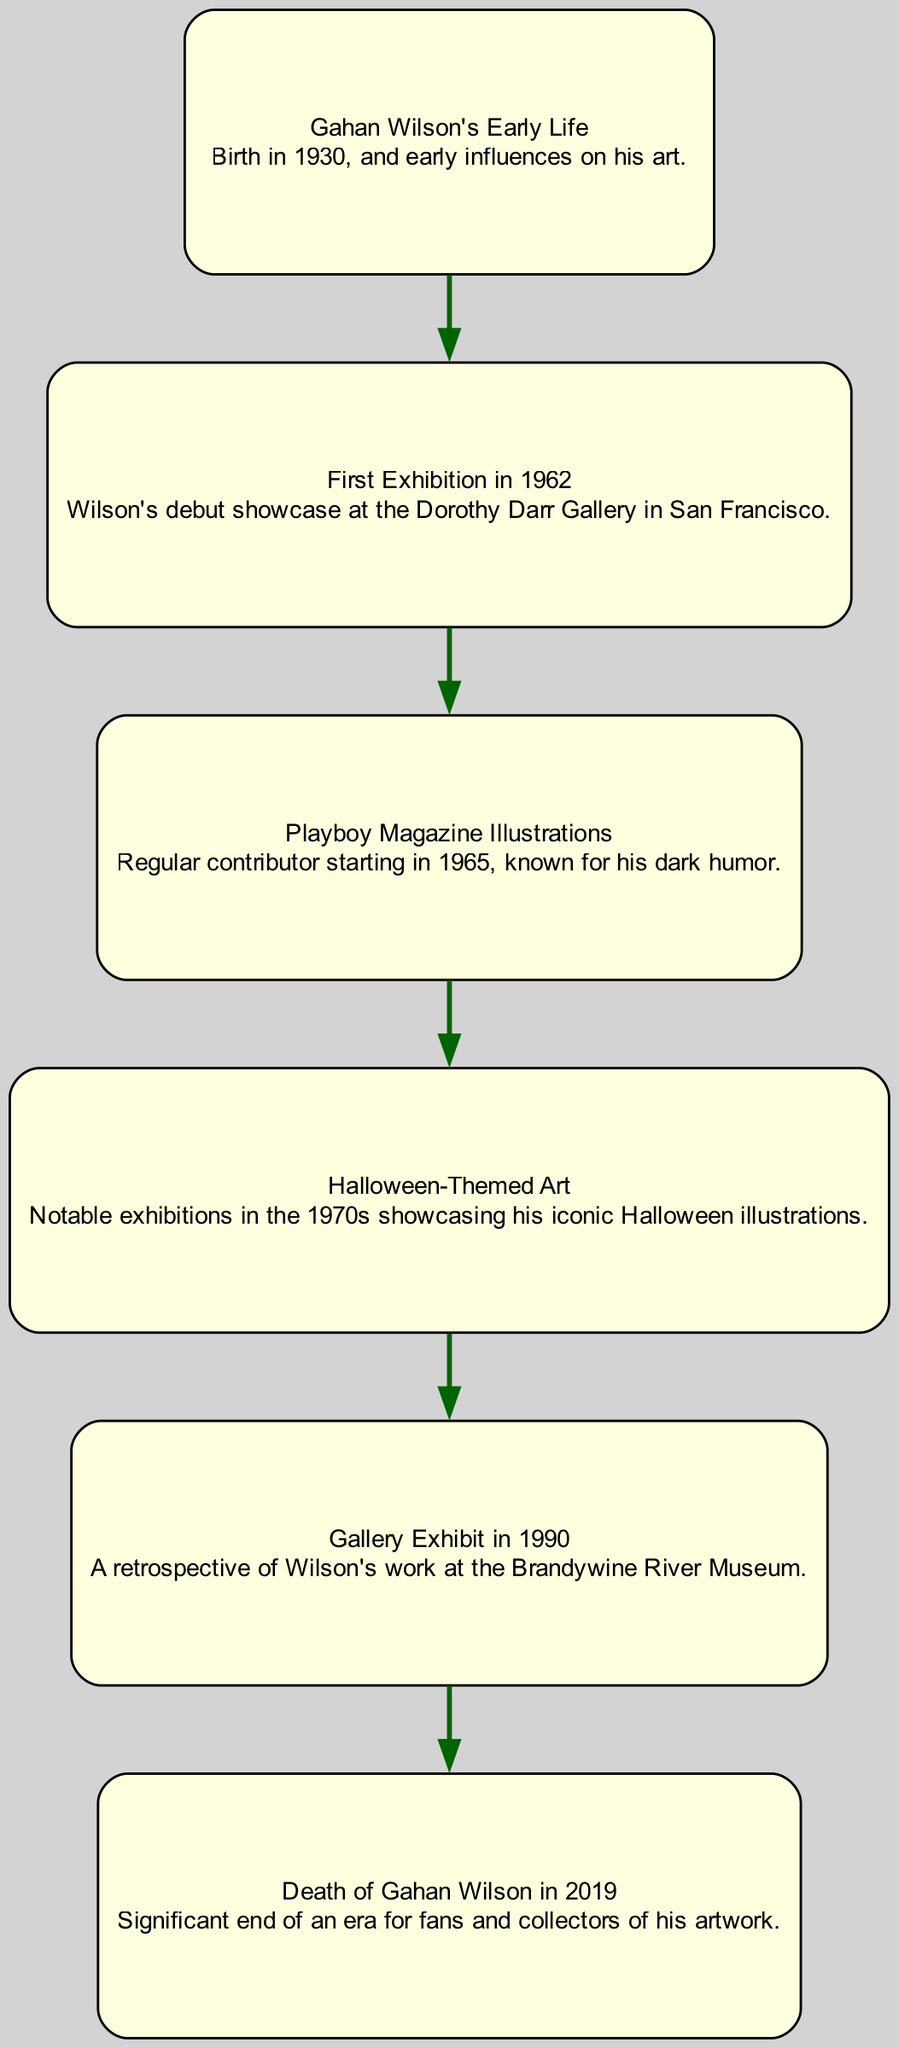What is the title of Gahan Wilson's first exhibition? The diagram indicates that Gahan Wilson's first exhibition is labeled "First Exhibition in 1962," which refers to his debut showcase at the Dorothy Darr Gallery.
Answer: First Exhibition in 1962 How many nodes are present in the diagram? The diagram contains a total of six nodes that represent different significant events in Gahan Wilson's artistic timeline, from his early life to his death.
Answer: 6 What were the illustrations that Gahan Wilson contributed to starting in 1965? The diagram connects the "Playboy Magazine Illustrations" after the "First Exhibition," indicating that he began contributing illustrations to Playboy Magazine during that time.
Answer: Playboy Magazine Illustrations Which exhibition followed the Halloween-themed art? According to the directed graph, the "Gallery Exhibit in 1990" is directly linked to "Halloween-Themed Art." Therefore, it is the exhibition that followed this theme.
Answer: Gallery Exhibit in 1990 What signifies the end of the timeline in the diagram? The last node in the directed graph is labeled "Death of Gahan Wilson in 2019," indicating that it represents the end of his artistic journey and timeline.
Answer: Death of Gahan Wilson in 2019 How did Gahan Wilson's artistic style evolve as shown in the connections of the diagram? The diagram illustrates a progression from early life influences, moving through his first exhibition, magazine illustrations, Halloween-themed art, culminating in a retrospective exhibit. This progression implies a growth in his thematic focus and public recognition over time.
Answer: Progression through exhibitions Which node indicates Gahan Wilson's connection to dark humor? The "Playboy Magazine Illustrations" node specifically mentions his work known for dark humor, establishing a clear connection between his art style and this characteristic.
Answer: Playboy Magazine Illustrations Which event in the timeline represents a retrospective of Wilson's work? The node labeled "Gallery Exhibit in 1990" indicates a retrospective, showcasing a comprehensive look at Gahan Wilson's body of work up to that point.
Answer: Gallery Exhibit in 1990 